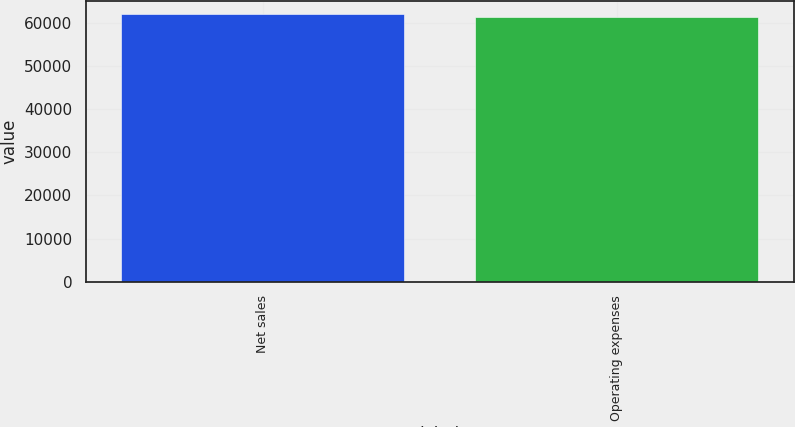Convert chart. <chart><loc_0><loc_0><loc_500><loc_500><bar_chart><fcel>Net sales<fcel>Operating expenses<nl><fcel>61947<fcel>61257<nl></chart> 